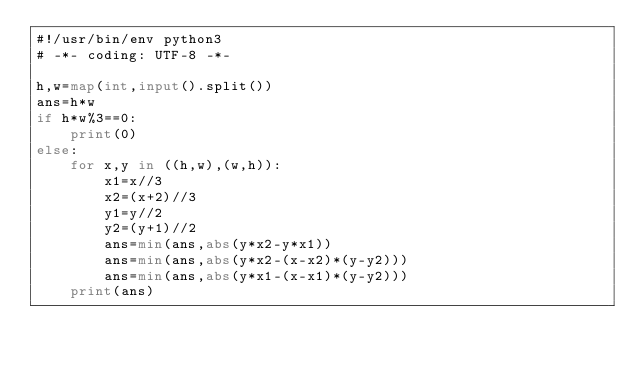Convert code to text. <code><loc_0><loc_0><loc_500><loc_500><_Python_>#!/usr/bin/env python3
# -*- coding: UTF-8 -*-

h,w=map(int,input().split())
ans=h*w
if h*w%3==0:
    print(0)
else:
    for x,y in ((h,w),(w,h)):
        x1=x//3
        x2=(x+2)//3
        y1=y//2
        y2=(y+1)//2
        ans=min(ans,abs(y*x2-y*x1))
        ans=min(ans,abs(y*x2-(x-x2)*(y-y2)))
        ans=min(ans,abs(y*x1-(x-x1)*(y-y2)))
    print(ans)
</code> 